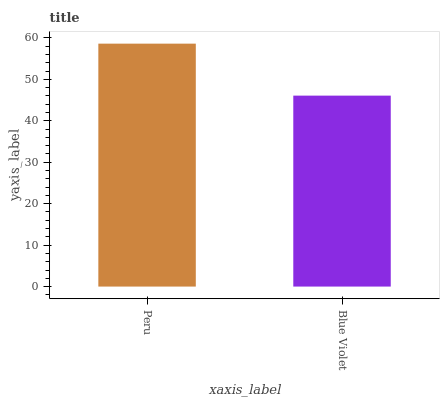Is Blue Violet the minimum?
Answer yes or no. Yes. Is Peru the maximum?
Answer yes or no. Yes. Is Blue Violet the maximum?
Answer yes or no. No. Is Peru greater than Blue Violet?
Answer yes or no. Yes. Is Blue Violet less than Peru?
Answer yes or no. Yes. Is Blue Violet greater than Peru?
Answer yes or no. No. Is Peru less than Blue Violet?
Answer yes or no. No. Is Peru the high median?
Answer yes or no. Yes. Is Blue Violet the low median?
Answer yes or no. Yes. Is Blue Violet the high median?
Answer yes or no. No. Is Peru the low median?
Answer yes or no. No. 